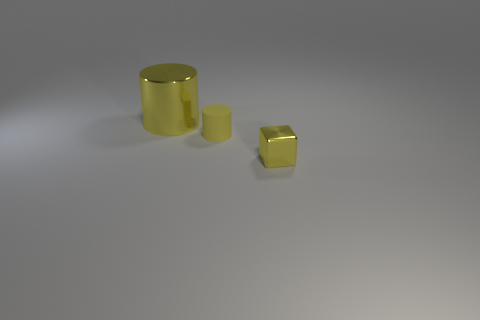Add 1 yellow shiny balls. How many objects exist? 4 Subtract all cylinders. How many objects are left? 1 Subtract 0 blue cylinders. How many objects are left? 3 Subtract all yellow matte things. Subtract all tiny matte spheres. How many objects are left? 2 Add 1 small yellow objects. How many small yellow objects are left? 3 Add 1 gray matte cylinders. How many gray matte cylinders exist? 1 